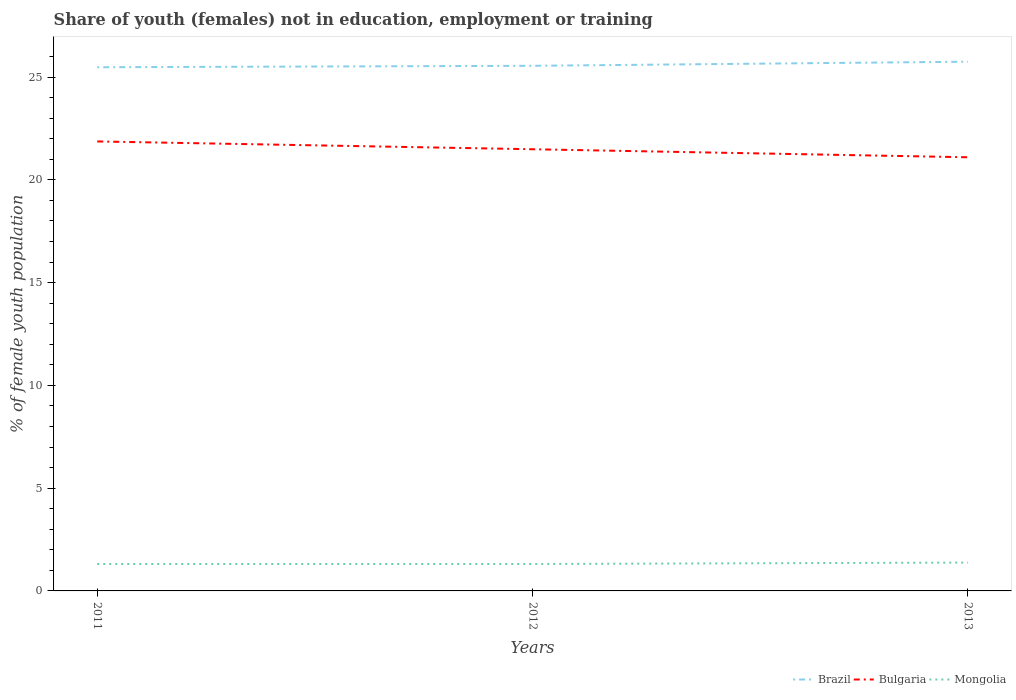Across all years, what is the maximum percentage of unemployed female population in in Brazil?
Ensure brevity in your answer.  25.48. What is the total percentage of unemployed female population in in Bulgaria in the graph?
Keep it short and to the point. 0.39. What is the difference between the highest and the second highest percentage of unemployed female population in in Mongolia?
Your answer should be compact. 0.07. What is the difference between the highest and the lowest percentage of unemployed female population in in Brazil?
Your answer should be very brief. 1. Is the percentage of unemployed female population in in Mongolia strictly greater than the percentage of unemployed female population in in Bulgaria over the years?
Offer a terse response. Yes. How many lines are there?
Ensure brevity in your answer.  3. How many years are there in the graph?
Your answer should be very brief. 3. What is the difference between two consecutive major ticks on the Y-axis?
Keep it short and to the point. 5. Are the values on the major ticks of Y-axis written in scientific E-notation?
Ensure brevity in your answer.  No. Does the graph contain any zero values?
Offer a terse response. No. Where does the legend appear in the graph?
Provide a succinct answer. Bottom right. How many legend labels are there?
Provide a short and direct response. 3. What is the title of the graph?
Offer a very short reply. Share of youth (females) not in education, employment or training. What is the label or title of the Y-axis?
Make the answer very short. % of female youth population. What is the % of female youth population of Brazil in 2011?
Your response must be concise. 25.48. What is the % of female youth population in Bulgaria in 2011?
Ensure brevity in your answer.  21.87. What is the % of female youth population of Mongolia in 2011?
Provide a succinct answer. 1.31. What is the % of female youth population in Brazil in 2012?
Your response must be concise. 25.55. What is the % of female youth population of Bulgaria in 2012?
Keep it short and to the point. 21.49. What is the % of female youth population in Mongolia in 2012?
Your answer should be very brief. 1.31. What is the % of female youth population in Brazil in 2013?
Offer a very short reply. 25.75. What is the % of female youth population of Bulgaria in 2013?
Provide a succinct answer. 21.1. What is the % of female youth population in Mongolia in 2013?
Your answer should be compact. 1.38. Across all years, what is the maximum % of female youth population of Brazil?
Your answer should be compact. 25.75. Across all years, what is the maximum % of female youth population in Bulgaria?
Provide a succinct answer. 21.87. Across all years, what is the maximum % of female youth population in Mongolia?
Ensure brevity in your answer.  1.38. Across all years, what is the minimum % of female youth population in Brazil?
Provide a short and direct response. 25.48. Across all years, what is the minimum % of female youth population of Bulgaria?
Your response must be concise. 21.1. Across all years, what is the minimum % of female youth population in Mongolia?
Make the answer very short. 1.31. What is the total % of female youth population in Brazil in the graph?
Your response must be concise. 76.78. What is the total % of female youth population in Bulgaria in the graph?
Make the answer very short. 64.46. What is the difference between the % of female youth population in Brazil in 2011 and that in 2012?
Provide a short and direct response. -0.07. What is the difference between the % of female youth population of Bulgaria in 2011 and that in 2012?
Offer a very short reply. 0.38. What is the difference between the % of female youth population in Mongolia in 2011 and that in 2012?
Your answer should be compact. 0. What is the difference between the % of female youth population of Brazil in 2011 and that in 2013?
Ensure brevity in your answer.  -0.27. What is the difference between the % of female youth population of Bulgaria in 2011 and that in 2013?
Make the answer very short. 0.77. What is the difference between the % of female youth population of Mongolia in 2011 and that in 2013?
Provide a short and direct response. -0.07. What is the difference between the % of female youth population in Brazil in 2012 and that in 2013?
Offer a terse response. -0.2. What is the difference between the % of female youth population of Bulgaria in 2012 and that in 2013?
Your response must be concise. 0.39. What is the difference between the % of female youth population of Mongolia in 2012 and that in 2013?
Make the answer very short. -0.07. What is the difference between the % of female youth population in Brazil in 2011 and the % of female youth population in Bulgaria in 2012?
Offer a very short reply. 3.99. What is the difference between the % of female youth population in Brazil in 2011 and the % of female youth population in Mongolia in 2012?
Keep it short and to the point. 24.17. What is the difference between the % of female youth population in Bulgaria in 2011 and the % of female youth population in Mongolia in 2012?
Make the answer very short. 20.56. What is the difference between the % of female youth population of Brazil in 2011 and the % of female youth population of Bulgaria in 2013?
Offer a terse response. 4.38. What is the difference between the % of female youth population of Brazil in 2011 and the % of female youth population of Mongolia in 2013?
Make the answer very short. 24.1. What is the difference between the % of female youth population in Bulgaria in 2011 and the % of female youth population in Mongolia in 2013?
Make the answer very short. 20.49. What is the difference between the % of female youth population in Brazil in 2012 and the % of female youth population in Bulgaria in 2013?
Your answer should be compact. 4.45. What is the difference between the % of female youth population in Brazil in 2012 and the % of female youth population in Mongolia in 2013?
Make the answer very short. 24.17. What is the difference between the % of female youth population in Bulgaria in 2012 and the % of female youth population in Mongolia in 2013?
Keep it short and to the point. 20.11. What is the average % of female youth population of Brazil per year?
Give a very brief answer. 25.59. What is the average % of female youth population of Bulgaria per year?
Your response must be concise. 21.49. What is the average % of female youth population of Mongolia per year?
Provide a succinct answer. 1.33. In the year 2011, what is the difference between the % of female youth population in Brazil and % of female youth population in Bulgaria?
Your response must be concise. 3.61. In the year 2011, what is the difference between the % of female youth population in Brazil and % of female youth population in Mongolia?
Your response must be concise. 24.17. In the year 2011, what is the difference between the % of female youth population in Bulgaria and % of female youth population in Mongolia?
Offer a terse response. 20.56. In the year 2012, what is the difference between the % of female youth population of Brazil and % of female youth population of Bulgaria?
Keep it short and to the point. 4.06. In the year 2012, what is the difference between the % of female youth population in Brazil and % of female youth population in Mongolia?
Give a very brief answer. 24.24. In the year 2012, what is the difference between the % of female youth population in Bulgaria and % of female youth population in Mongolia?
Your answer should be compact. 20.18. In the year 2013, what is the difference between the % of female youth population of Brazil and % of female youth population of Bulgaria?
Ensure brevity in your answer.  4.65. In the year 2013, what is the difference between the % of female youth population of Brazil and % of female youth population of Mongolia?
Provide a short and direct response. 24.37. In the year 2013, what is the difference between the % of female youth population in Bulgaria and % of female youth population in Mongolia?
Offer a very short reply. 19.72. What is the ratio of the % of female youth population of Bulgaria in 2011 to that in 2012?
Provide a succinct answer. 1.02. What is the ratio of the % of female youth population in Mongolia in 2011 to that in 2012?
Offer a terse response. 1. What is the ratio of the % of female youth population in Brazil in 2011 to that in 2013?
Provide a succinct answer. 0.99. What is the ratio of the % of female youth population in Bulgaria in 2011 to that in 2013?
Ensure brevity in your answer.  1.04. What is the ratio of the % of female youth population in Mongolia in 2011 to that in 2013?
Your response must be concise. 0.95. What is the ratio of the % of female youth population in Bulgaria in 2012 to that in 2013?
Make the answer very short. 1.02. What is the ratio of the % of female youth population of Mongolia in 2012 to that in 2013?
Your answer should be very brief. 0.95. What is the difference between the highest and the second highest % of female youth population in Brazil?
Your answer should be very brief. 0.2. What is the difference between the highest and the second highest % of female youth population in Bulgaria?
Keep it short and to the point. 0.38. What is the difference between the highest and the second highest % of female youth population in Mongolia?
Offer a very short reply. 0.07. What is the difference between the highest and the lowest % of female youth population of Brazil?
Make the answer very short. 0.27. What is the difference between the highest and the lowest % of female youth population in Bulgaria?
Keep it short and to the point. 0.77. What is the difference between the highest and the lowest % of female youth population in Mongolia?
Offer a terse response. 0.07. 